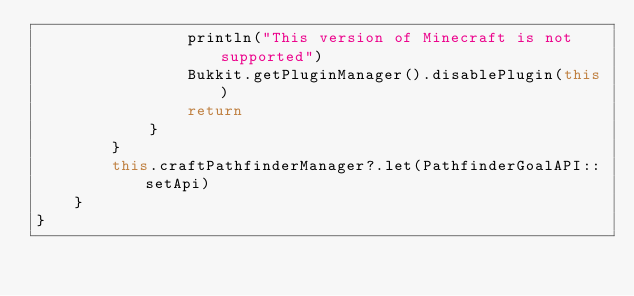<code> <loc_0><loc_0><loc_500><loc_500><_Kotlin_>                println("This version of Minecraft is not supported")
                Bukkit.getPluginManager().disablePlugin(this)
                return
            }
        }
        this.craftPathfinderManager?.let(PathfinderGoalAPI::setApi)
    }
}
</code> 